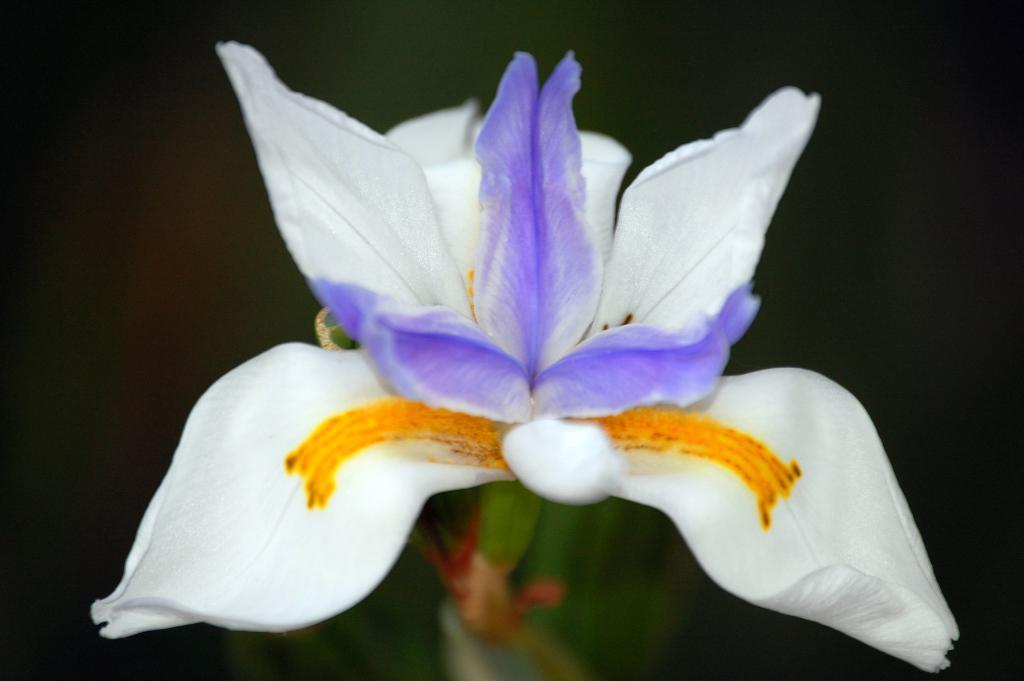What is the main subject of the image? There is a flower in the image. Can you describe the background of the image? The background of the image is blurred. What else can be seen at the bottom of the image? There are stems visible at the bottom of the image. How many elbows can be seen in the image? There are no elbows present in the image, as it features a flower with stems. Is there a trail visible in the image? There is no trail visible in the image; it features a flower with a blurred background. 